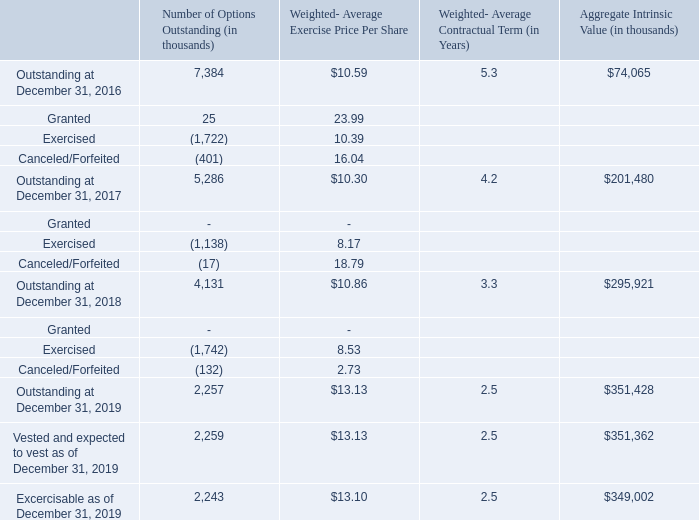A summary of option activity under all of the Company’s equity incentive plans at December 31, 2019 and changes during the period then ended is presented in the following table:
There were no options granted for the year ended December 31, 2019 and 2018. The total intrinsic value of options exercised during year ended December 31, 2019, 2018 and 2017 were $215.5 million, $74.6 million, and $41.2 million, respectively.
What are the respective intrinsic value of options exercised in the year ended December 31, 2019 and 2018? $215.5 million, $74.6 million. What are the respective intrinsic value of options exercised in the year ended December 31, 2018 and 2017? $74.6 million, $41.2 million. What is the weighted average price per share of granted in 2017? 23.99. What is the percentage change in the total intrinsic value of options exercised during year ended December 31, 2019 and 2018?
Answer scale should be: percent. (215.5 - 74.6)/74.6 
Answer: 188.87. What is the average total intrinsic value of options exercised during year ended December 31, 2017 to 2019?
Answer scale should be: million. (215.5 + 74.6 + 41.2)/3 
Answer: 110.43. What is the percentage change in the number of outstanding options between December 31, 2016 and 2017?
Answer scale should be: percent. (5,286- 7,384)/ 7,384 
Answer: -28.41. 